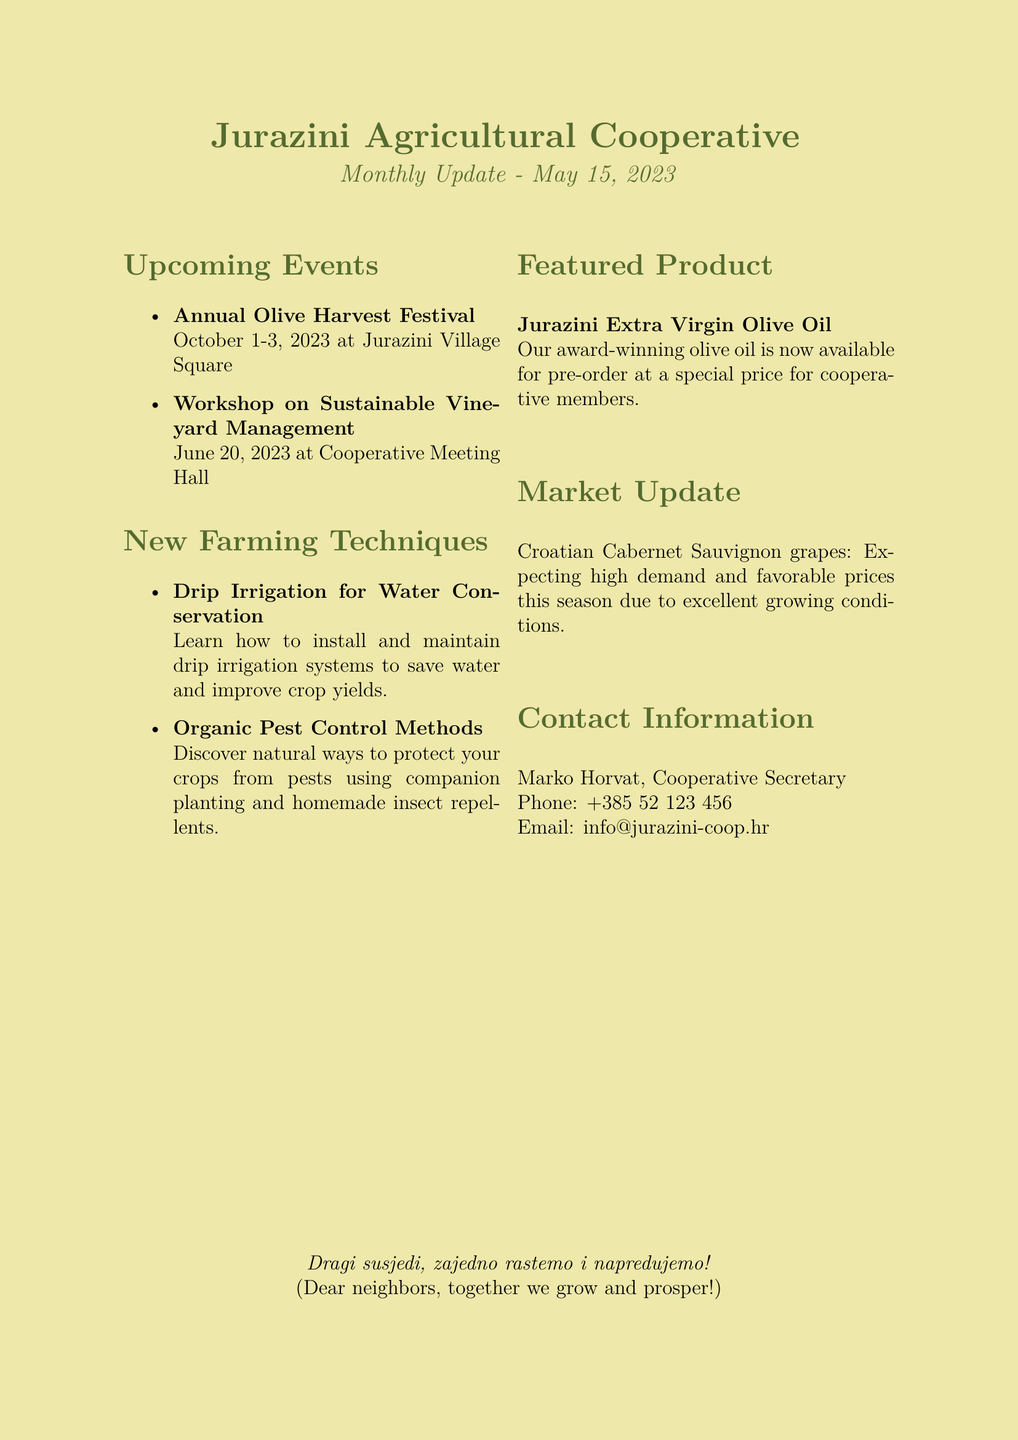what is the newsletter title? The title of the newsletter is stated at the beginning of the document.
Answer: Jurazini Agricultural Cooperative Monthly Update when is the Annual Olive Harvest Festival? The date of the festival is listed in the upcoming events section.
Answer: October 1-3, 2023 where will the Workshop on Sustainable Vineyard Management take place? The location is specified under the upcoming events section.
Answer: Cooperative Meeting Hall what farming technique helps with water conservation? The document provides a name for the technique focused on water savings.
Answer: Drip Irrigation for Water Conservation who can be contacted for more information? The contact information section includes the name of the secretary for inquiries.
Answer: Marko Horvat what product is available for pre-order? The featured product is highlighted in its own section with specifics about availability.
Answer: Jurazini Extra Virgin Olive Oil which crop is mentioned in the market update? The market update section identifies a specific crop related to current market conditions.
Answer: Croatian Cabernet Sauvignon grapes what is the expected market condition for the mentioned crop? The document includes a forecast about the market situation for the crop listed.
Answer: High demand and favorable prices what is the date of the workshop? The document specifies the date in the upcoming events section for the workshop.
Answer: June 20, 2023 